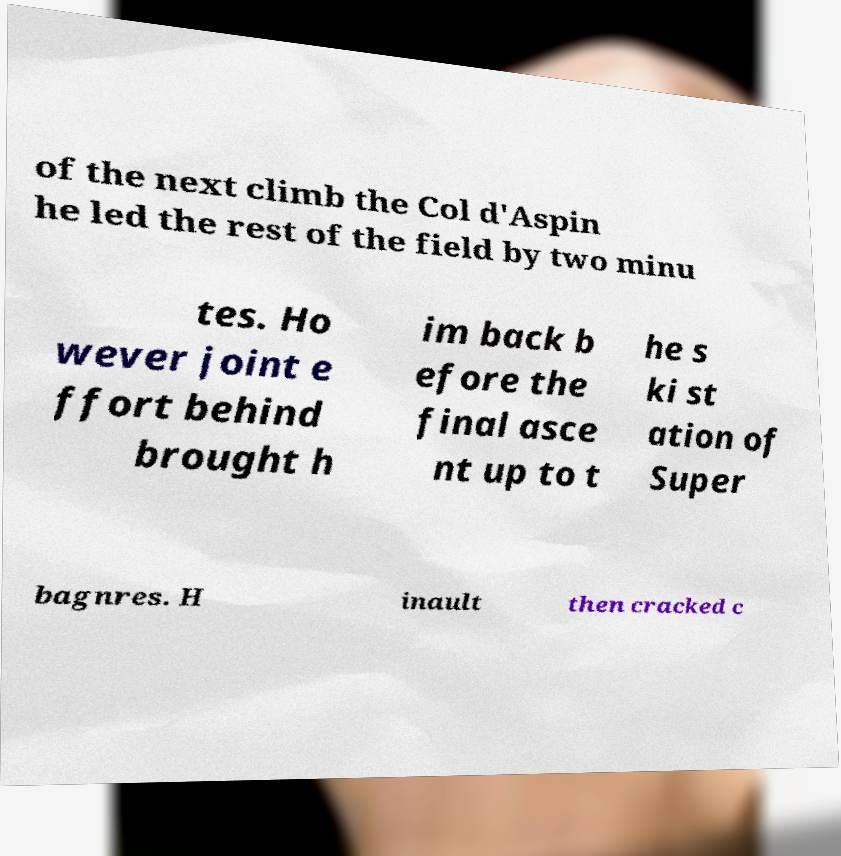I need the written content from this picture converted into text. Can you do that? of the next climb the Col d'Aspin he led the rest of the field by two minu tes. Ho wever joint e ffort behind brought h im back b efore the final asce nt up to t he s ki st ation of Super bagnres. H inault then cracked c 